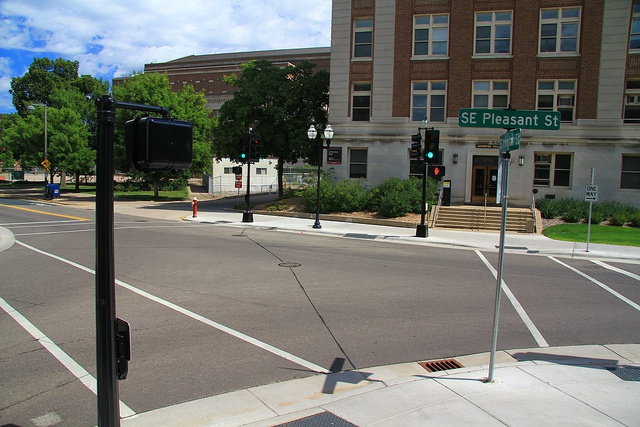Describe the objects in this image and their specific colors. I can see traffic light in gray, black, darkgray, and maroon tones, traffic light in gray, black, and cyan tones, traffic light in gray, black, cyan, darkgreen, and teal tones, traffic light in gray, black, and darkgreen tones, and traffic light in gray, black, and red tones in this image. 